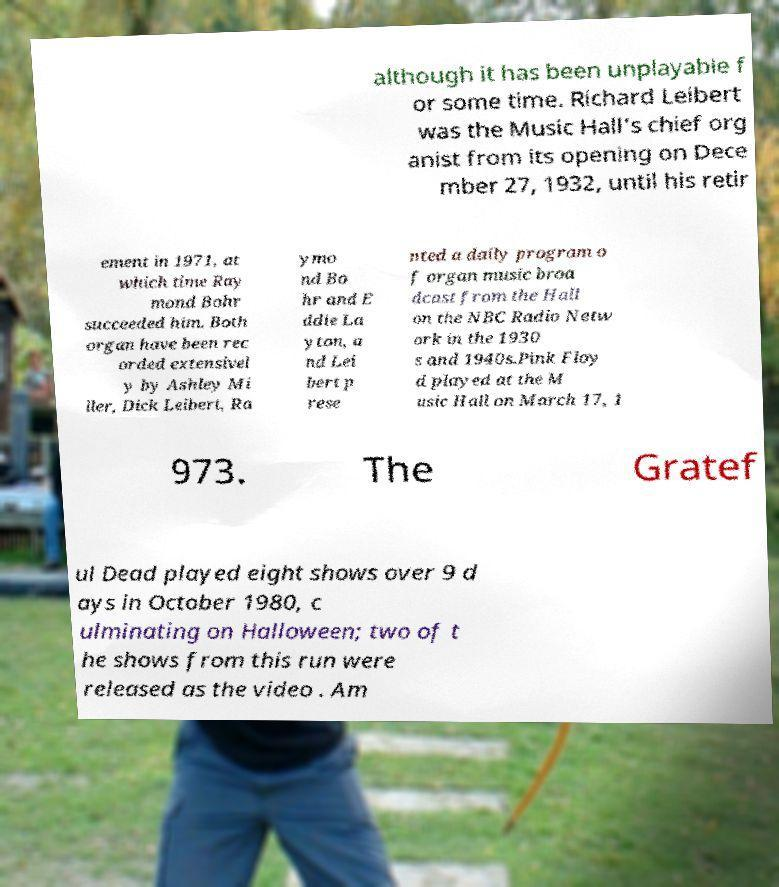Can you read and provide the text displayed in the image?This photo seems to have some interesting text. Can you extract and type it out for me? although it has been unplayable f or some time. Richard Leibert was the Music Hall's chief org anist from its opening on Dece mber 27, 1932, until his retir ement in 1971, at which time Ray mond Bohr succeeded him. Both organ have been rec orded extensivel y by Ashley Mi ller, Dick Leibert, Ra ymo nd Bo hr and E ddie La yton, a nd Lei bert p rese nted a daily program o f organ music broa dcast from the Hall on the NBC Radio Netw ork in the 1930 s and 1940s.Pink Floy d played at the M usic Hall on March 17, 1 973. The Gratef ul Dead played eight shows over 9 d ays in October 1980, c ulminating on Halloween; two of t he shows from this run were released as the video . Am 